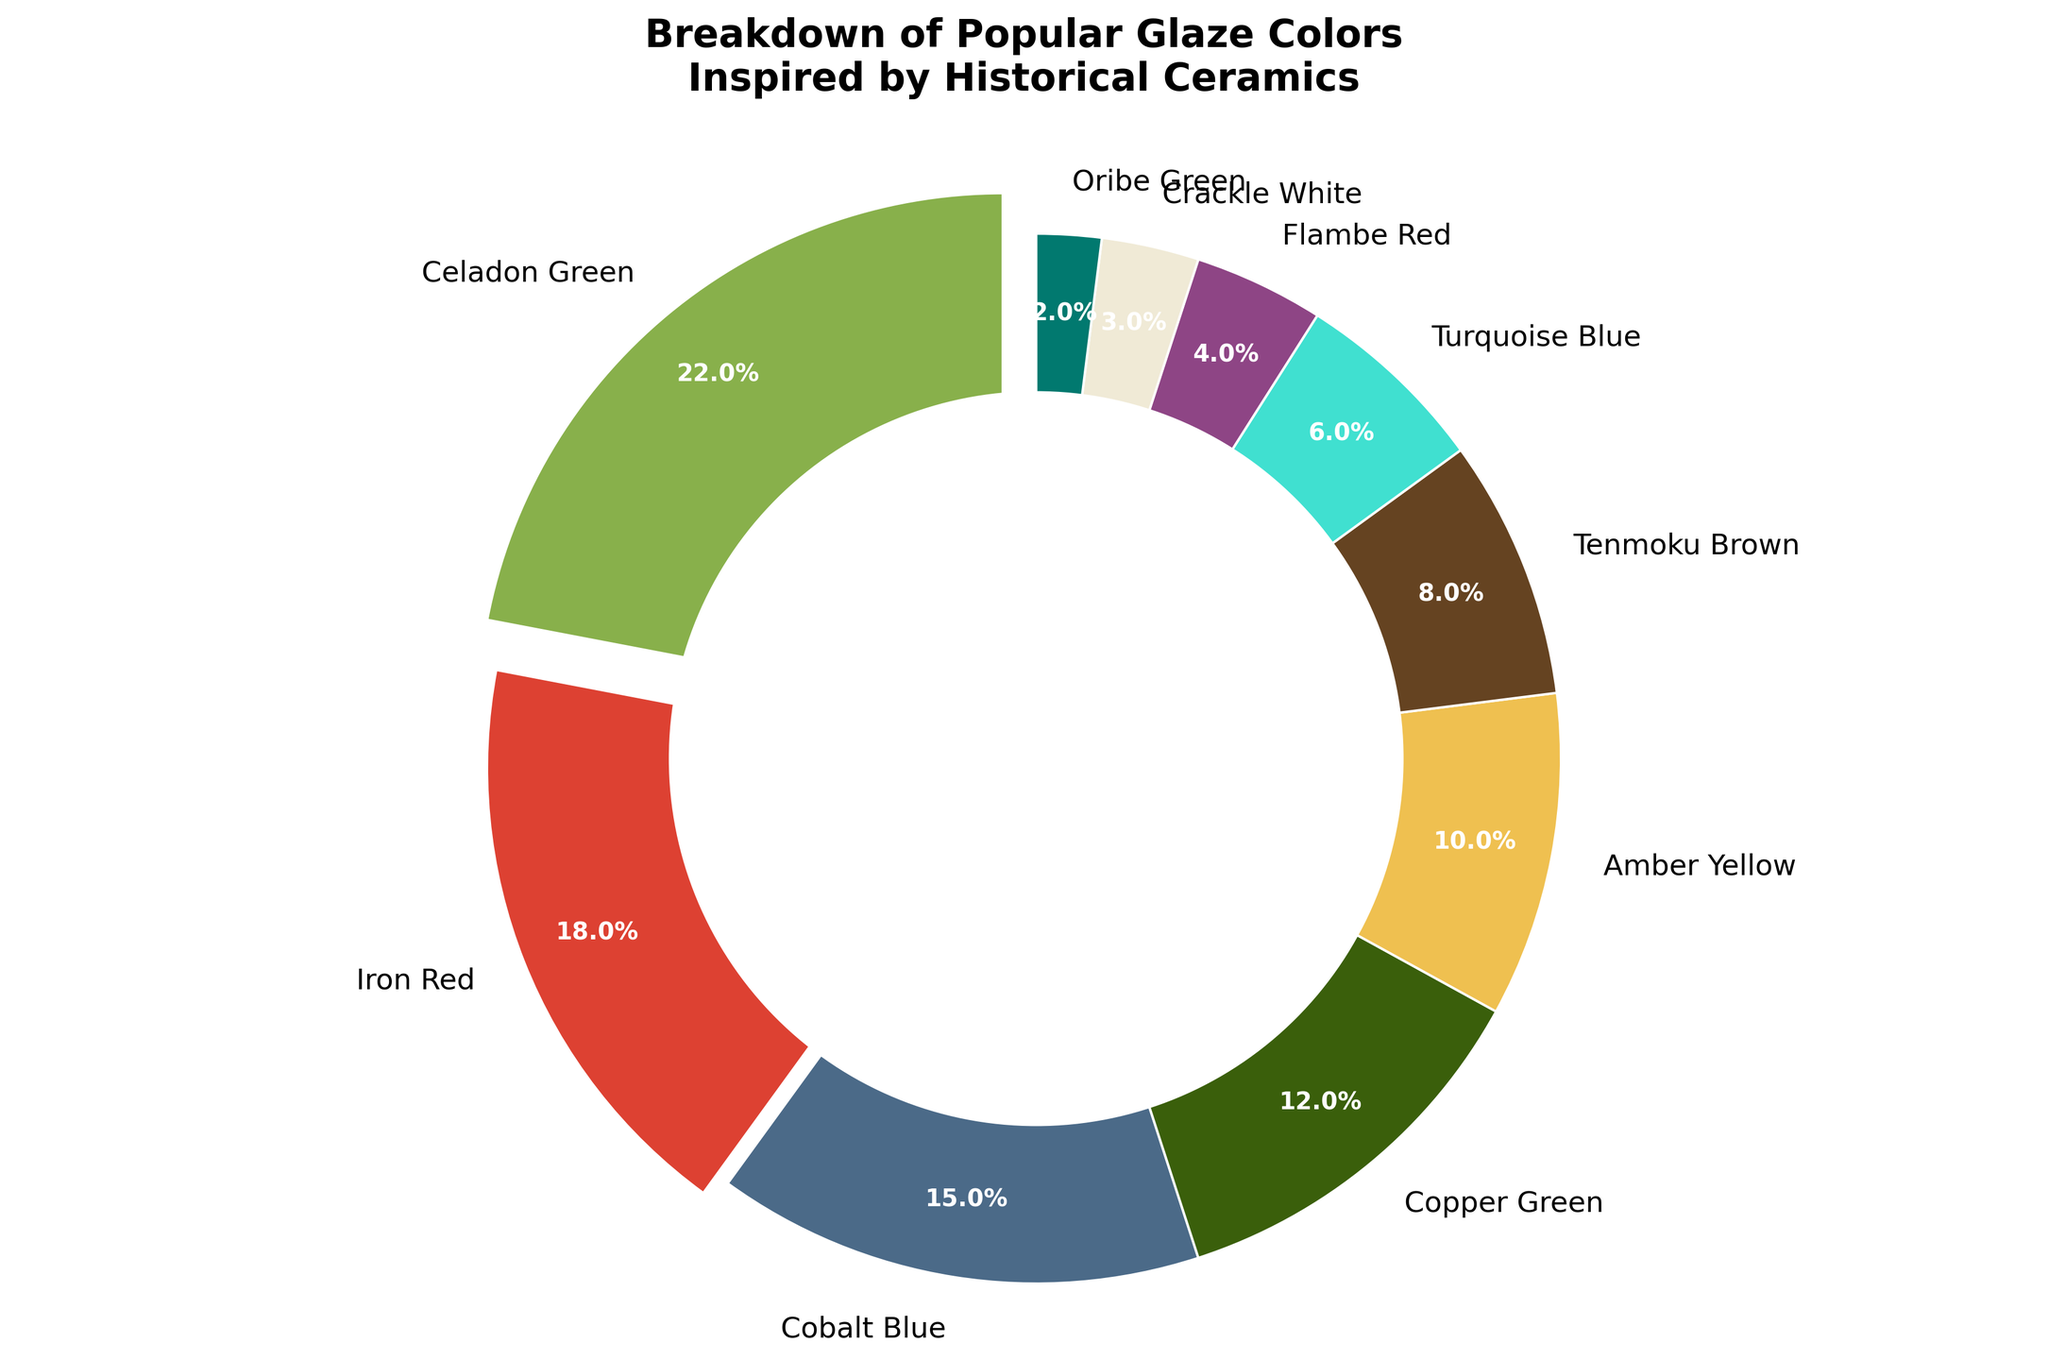What is the percentage of Celadon Green? The pie chart segment labeled "Celadon Green" shows the percentage directly.
Answer: 22% Which color has the lowest representation in the chart? By looking at the pie chart segments and their labels, "Oribe Green" has the smallest segment.
Answer: Oribe Green What is the combined percentage of colors Blue (Cobalt Blue and Turquoise Blue)? The pie chart segments for "Cobalt Blue" and "Turquoise Blue" show 15% and 6%, respectively. Adding these gives 15% + 6% = 21%.
Answer: 21% How does the percentage of Iron Red compare to the percentage of Amber Yellow? Refer to the pie chart segments labeled "Iron Red" and "Amber Yellow" which show 18% and 10%, respectively.
Answer: Iron Red is 8% higher than Amber Yellow Which color has a percentage closest to the average percentage of all colors? Calculate the average by summing all percentages and dividing by the number of colors: (22%+18%+15%+12%+10%+8%+6%+4%+3%+2%) / 10 = 10%. The closest percentage to this is Amber Yellow.
Answer: Amber Yellow By how much does the percentage of Tenmoku Brown differ from that of Copper Green? The pie chart segments for "Tenmoku Brown" and "Copper Green" show 8% and 12%, respectively. The difference is 12% - 8% = 4%.
Answer: 4% What is the total percentage of all green shades combined (Celadon Green, Copper Green, and Oribe Green)? The pie chart segments for "Celadon Green," "Copper Green," and "Oribe Green" show 22%, 12%, and 2%, respectively. Adding these gives 22% + 12% + 2% = 36%.
Answer: 36% Which three colors have the highest representation, and what is their combined percentage? The three largest segments are "Celadon Green" (22%), "Iron Red" (18%), and "Cobalt Blue" (15%). Adding these gives 22% + 18% + 15% = 55%.
Answer: Celadon Green, Iron Red, Cobalt Blue (55%) How many colors have a percentage representation of less than 10%? The pie chart segments with percentages less than 10% are "Tenmoku Brown" (8%), "Turquoise Blue" (6%), "Flambe Red" (4%), "Crackle White" (3%), and "Oribe Green" (2%). Counting these gives 5 colors.
Answer: 5 colors 